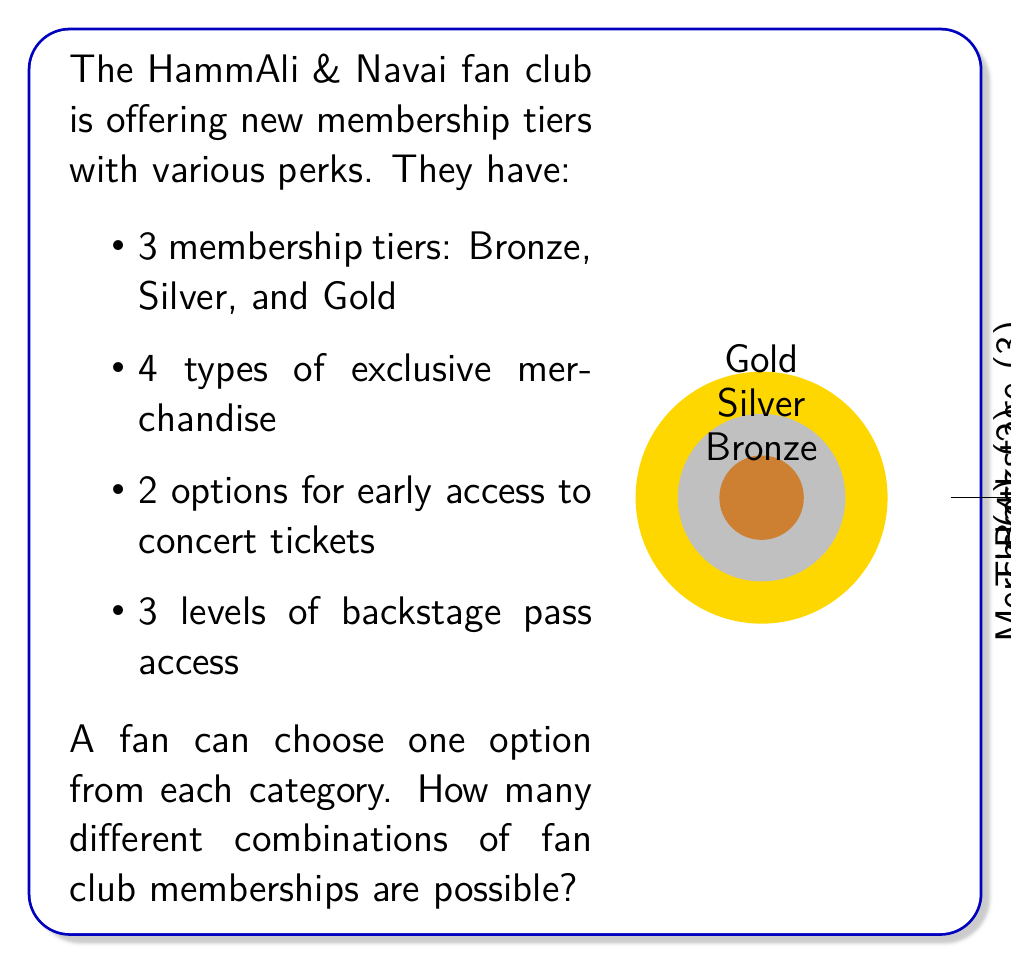Give your solution to this math problem. To solve this problem, we'll use the multiplication principle of combinatorics. This principle states that if we have a sequence of independent choices, the total number of possible outcomes is the product of the number of possibilities for each choice.

Let's break down the choices:

1. Membership tiers: 3 options
2. Exclusive merchandise: 4 options
3. Early access to concert tickets: 2 options
4. Backstage pass access: 3 options

Since a fan can choose one option from each category, and the choices are independent of each other, we multiply the number of options for each category:

$$\text{Total combinations} = 3 \times 4 \times 2 \times 3$$

Now, let's calculate:

$$\begin{align}
\text{Total combinations} &= 3 \times 4 \times 2 \times 3 \\
&= 12 \times 2 \times 3 \\
&= 24 \times 3 \\
&= 72
\end{align}$$

Therefore, there are 72 different possible combinations of fan club memberships.
Answer: 72 